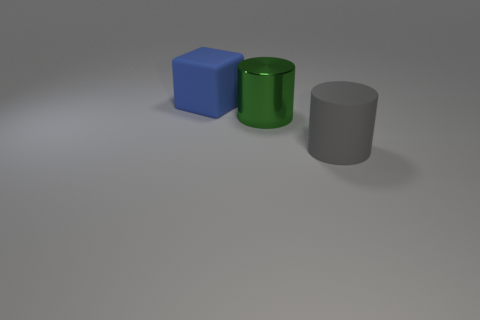Subtract all green cylinders. How many cylinders are left? 1 Add 1 small purple cylinders. How many objects exist? 4 Subtract 1 cubes. How many cubes are left? 0 Add 3 large green cylinders. How many large green cylinders are left? 4 Add 3 small green objects. How many small green objects exist? 3 Subtract 0 brown blocks. How many objects are left? 3 Subtract all cylinders. How many objects are left? 1 Subtract all gray cylinders. Subtract all brown balls. How many cylinders are left? 1 Subtract all yellow balls. How many green cylinders are left? 1 Subtract all yellow metal cylinders. Subtract all gray matte cylinders. How many objects are left? 2 